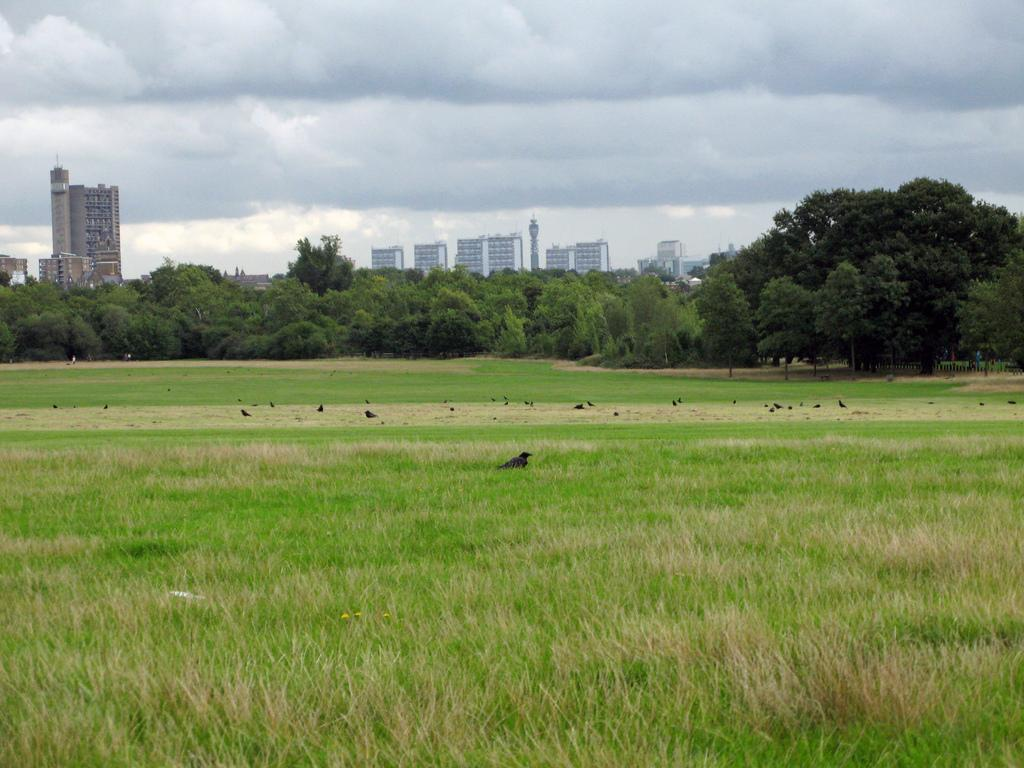What animals can be seen on the grass in the image? There are birds on the grass in the image. What type of vegetation is visible in the background of the image? There are trees in the background of the image. What type of structures can be seen in the background of the image? There are buildings in the background of the image. What can be seen in the sky in the background of the image? There are clouds in the sky in the background of the image. What type of rings can be seen on the birds' beaks in the image? There are no rings visible on the birds' beaks in the image. How does the image convey a sense of disgust? The image does not convey a sense of disgust; it is a neutral representation of birds on the grass with trees, buildings, and clouds in the background. 